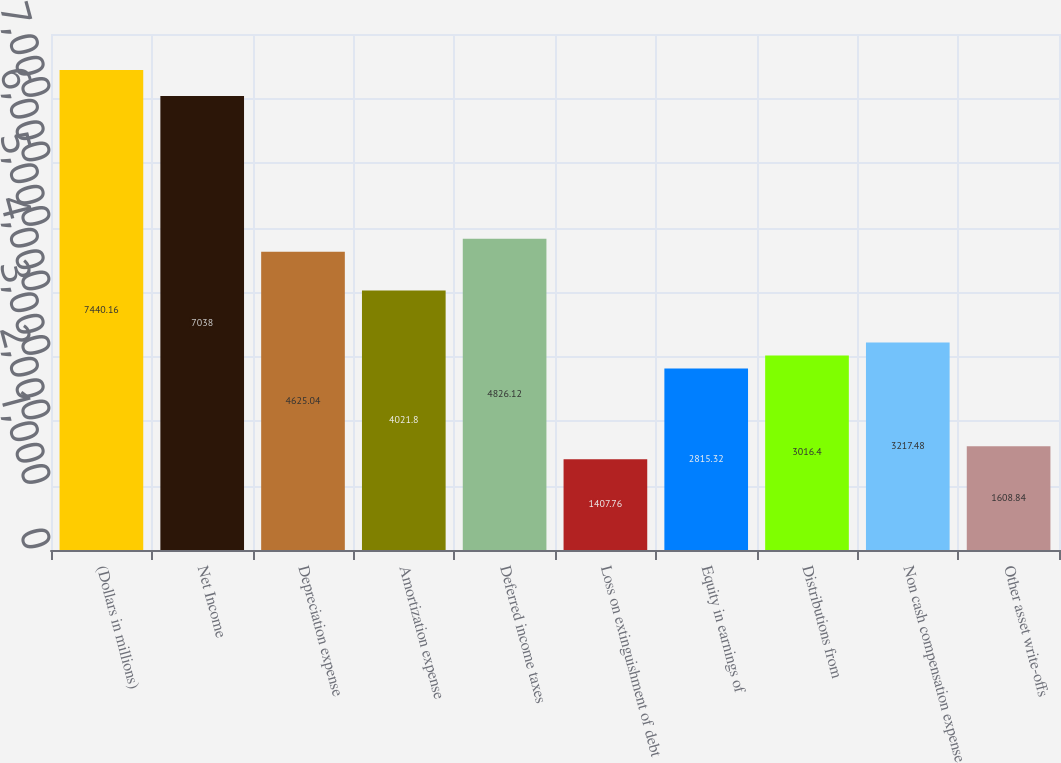Convert chart. <chart><loc_0><loc_0><loc_500><loc_500><bar_chart><fcel>(Dollars in millions)<fcel>Net Income<fcel>Depreciation expense<fcel>Amortization expense<fcel>Deferred income taxes<fcel>Loss on extinguishment of debt<fcel>Equity in earnings of<fcel>Distributions from<fcel>Non cash compensation expense<fcel>Other asset write-offs<nl><fcel>7440.16<fcel>7038<fcel>4625.04<fcel>4021.8<fcel>4826.12<fcel>1407.76<fcel>2815.32<fcel>3016.4<fcel>3217.48<fcel>1608.84<nl></chart> 